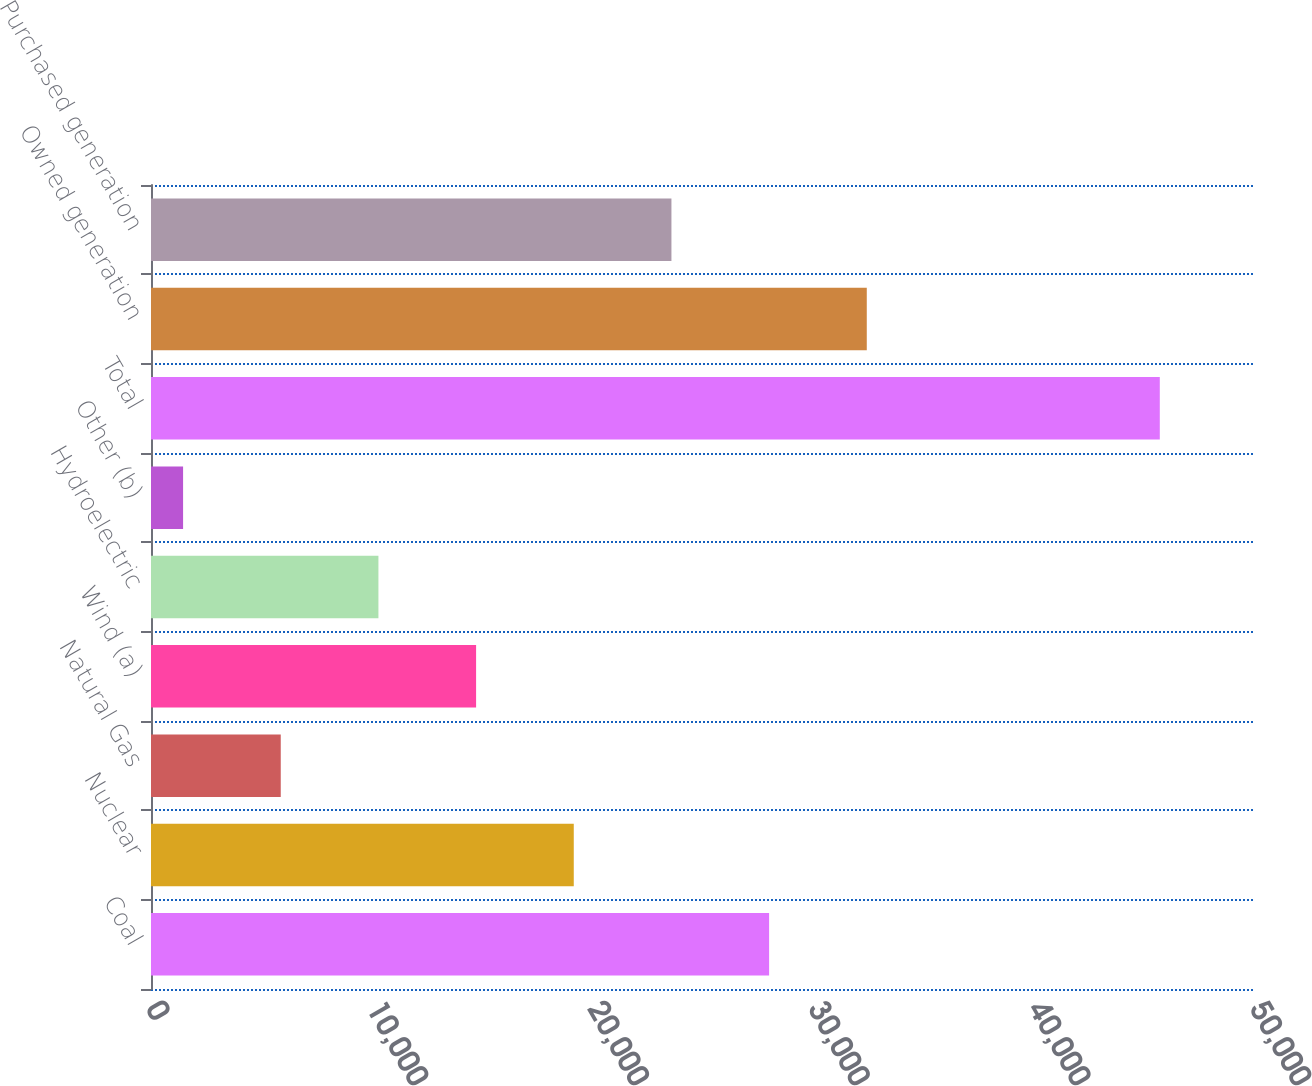Convert chart to OTSL. <chart><loc_0><loc_0><loc_500><loc_500><bar_chart><fcel>Coal<fcel>Nuclear<fcel>Natural Gas<fcel>Wind (a)<fcel>Hydroelectric<fcel>Other (b)<fcel>Total<fcel>Owned generation<fcel>Purchased generation<nl><fcel>27994<fcel>19147<fcel>5876.5<fcel>14723.5<fcel>10300<fcel>1453<fcel>45688<fcel>32417.5<fcel>23570.5<nl></chart> 